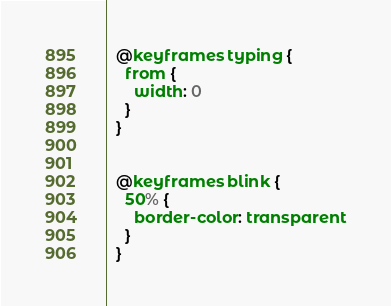Convert code to text. <code><loc_0><loc_0><loc_500><loc_500><_CSS_>  @keyframes typing {
    from {
      width: 0
    }
  }

        
  @keyframes blink {
    50% {
      border-color: transparent
    }
  }</code> 